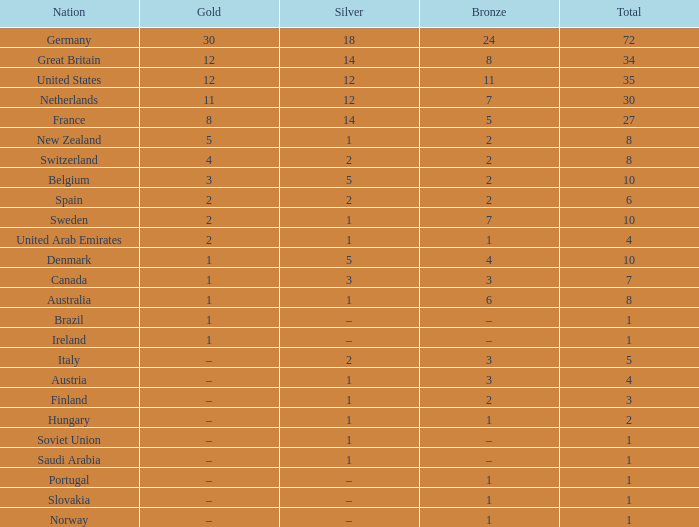I'm looking to parse the entire table for insights. Could you assist me with that? {'header': ['Nation', 'Gold', 'Silver', 'Bronze', 'Total'], 'rows': [['Germany', '30', '18', '24', '72'], ['Great Britain', '12', '14', '8', '34'], ['United States', '12', '12', '11', '35'], ['Netherlands', '11', '12', '7', '30'], ['France', '8', '14', '5', '27'], ['New Zealand', '5', '1', '2', '8'], ['Switzerland', '4', '2', '2', '8'], ['Belgium', '3', '5', '2', '10'], ['Spain', '2', '2', '2', '6'], ['Sweden', '2', '1', '7', '10'], ['United Arab Emirates', '2', '1', '1', '4'], ['Denmark', '1', '5', '4', '10'], ['Canada', '1', '3', '3', '7'], ['Australia', '1', '1', '6', '8'], ['Brazil', '1', '–', '–', '1'], ['Ireland', '1', '–', '–', '1'], ['Italy', '–', '2', '3', '5'], ['Austria', '–', '1', '3', '4'], ['Finland', '–', '1', '2', '3'], ['Hungary', '–', '1', '1', '2'], ['Soviet Union', '–', '1', '–', '1'], ['Saudi Arabia', '–', '1', '–', '1'], ['Portugal', '–', '–', '1', '1'], ['Slovakia', '–', '–', '1', '1'], ['Norway', '–', '–', '1', '1']]} If the total is 6, what is the value of gold? 2.0. 